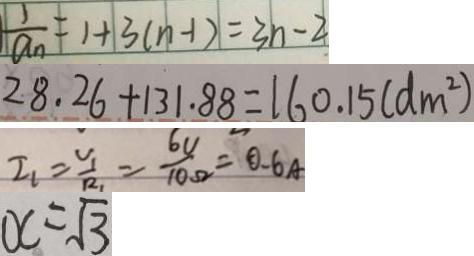<formula> <loc_0><loc_0><loc_500><loc_500>\frac { 1 } { a _ { n } } = 1 + 3 ( n - 1 ) = 3 n - 2 
 2 8 . 2 6 + 1 3 1 . 8 8 = 1 6 0 . 1 5 ( d m ^ { 2 } ) 
 I _ { 1 } = \frac { v _ { 1 } } { R _ { 1 } } = \frac { 6 v } { 1 0 \Omega } = 0 . 6 A 
 x = \sqrt { 3 }</formula> 